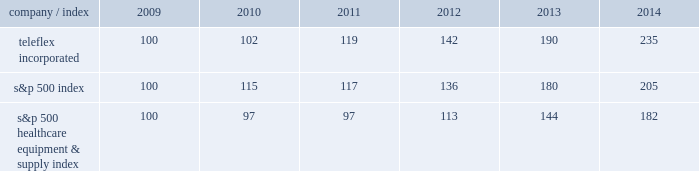Stock performance graph the following graph provides a comparison of five year cumulative total stockholder returns of teleflex common stock , the standard & poor 2019s ( s&p ) 500 stock index and the s&p 500 healthcare equipment & supply index .
The annual changes for the five-year period shown on the graph are based on the assumption that $ 100 had been invested in teleflex common stock and each index on december 31 , 2009 and that all dividends were reinvested .
Market performance .
S&p 500 healthcare equipment & supply index 100 97 97 113 144 182 .
What is the rate of return of an investment in teleflex incorporated from 2010 to 2011? 
Computations: ((119 - 102) / 102)
Answer: 0.16667. 